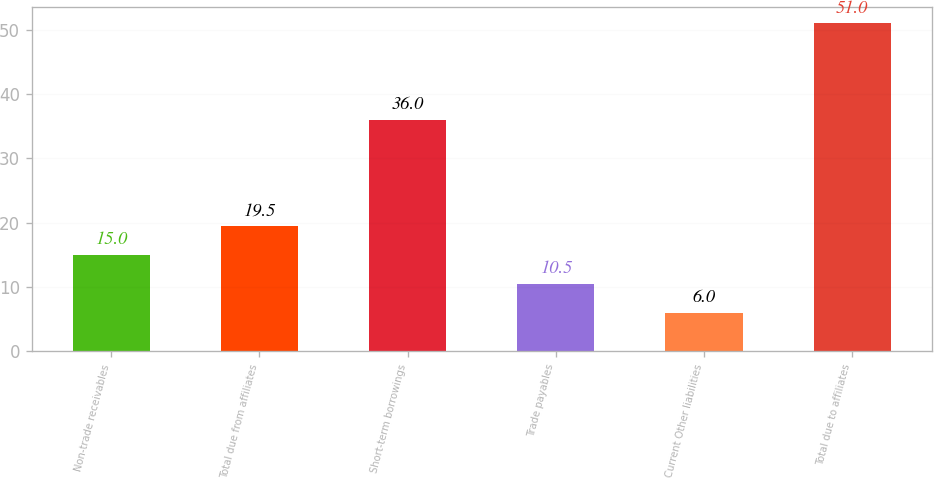Convert chart. <chart><loc_0><loc_0><loc_500><loc_500><bar_chart><fcel>Non-trade receivables<fcel>Total due from affiliates<fcel>Short-term borrowings<fcel>Trade payables<fcel>Current Other liabilities<fcel>Total due to affiliates<nl><fcel>15<fcel>19.5<fcel>36<fcel>10.5<fcel>6<fcel>51<nl></chart> 